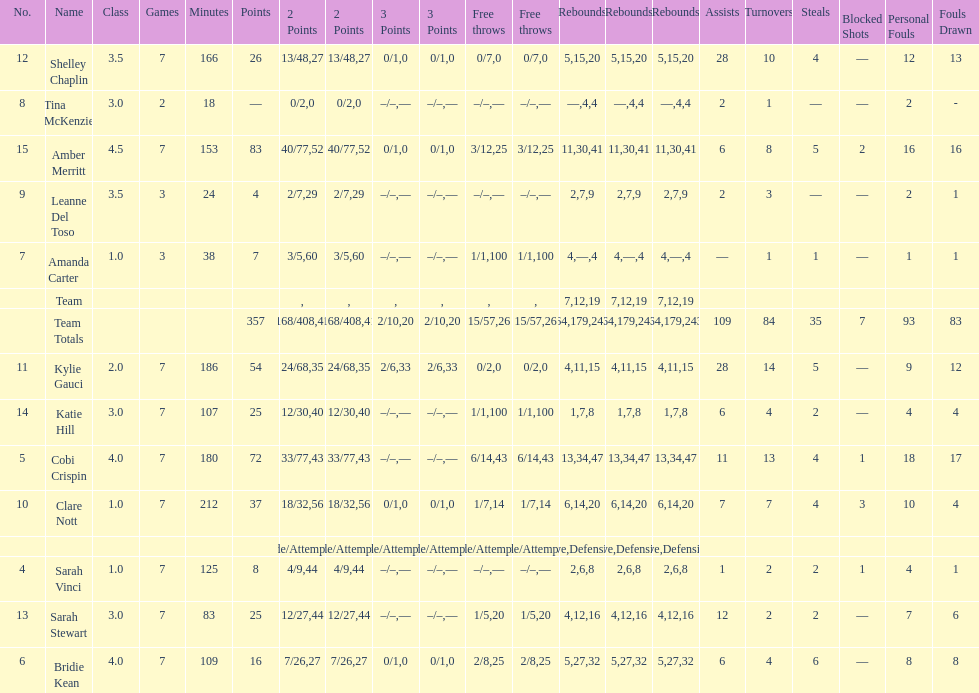Who had more steals than any other player? Bridie Kean. 